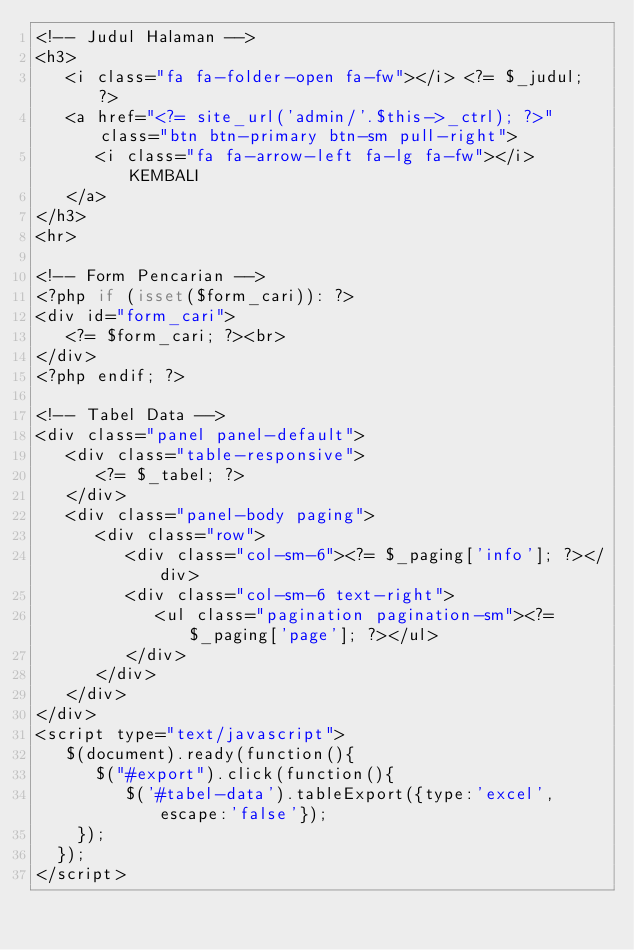Convert code to text. <code><loc_0><loc_0><loc_500><loc_500><_PHP_><!-- Judul Halaman -->
<h3>
   <i class="fa fa-folder-open fa-fw"></i> <?= $_judul; ?>
   <a href="<?= site_url('admin/'.$this->_ctrl); ?>" class="btn btn-primary btn-sm pull-right">
      <i class="fa fa-arrow-left fa-lg fa-fw"></i> KEMBALI
   </a>
</h3>
<hr>

<!-- Form Pencarian -->
<?php if (isset($form_cari)): ?>
<div id="form_cari">
   <?= $form_cari; ?><br>
</div>
<?php endif; ?>

<!-- Tabel Data -->
<div class="panel panel-default">
   <div class="table-responsive">
      <?= $_tabel; ?>
   </div>
   <div class="panel-body paging">
      <div class="row">
         <div class="col-sm-6"><?= $_paging['info']; ?></div>
         <div class="col-sm-6 text-right">
            <ul class="pagination pagination-sm"><?= $_paging['page']; ?></ul>
         </div>
      </div>
   </div>
</div>
<script type="text/javascript">
   $(document).ready(function(){
      $("#export").click(function(){
         $('#tabel-data').tableExport({type:'excel',escape:'false'});
    });
  });
</script></code> 